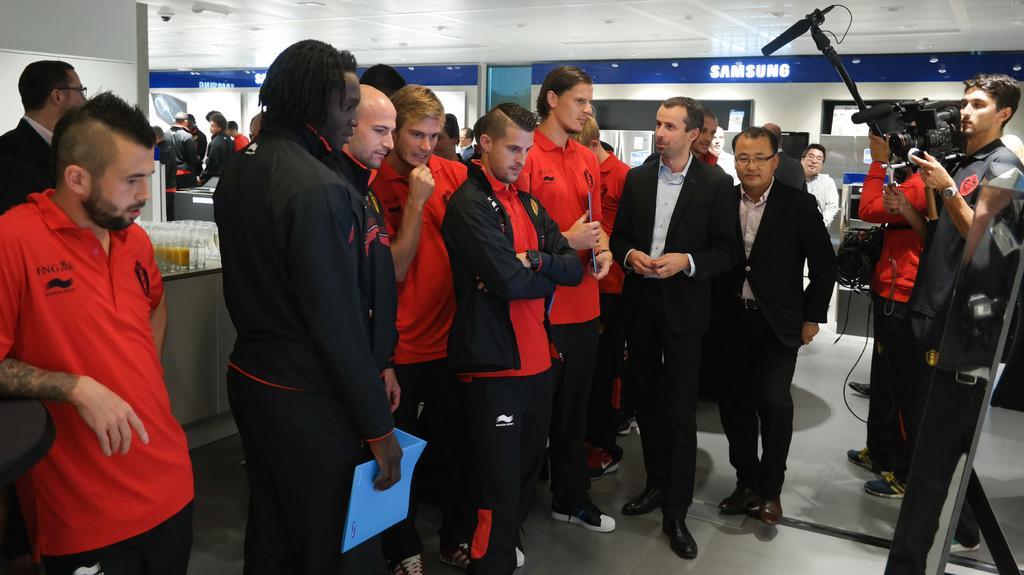Please provide a concise description of this image. In this image we can see there are people standing and there are a few people holding files and few people holding a camera. And there is the table, on the table there are glasses with juice. And there is the stand. There is the wall with board and papers. At the top there is the ceiling. 